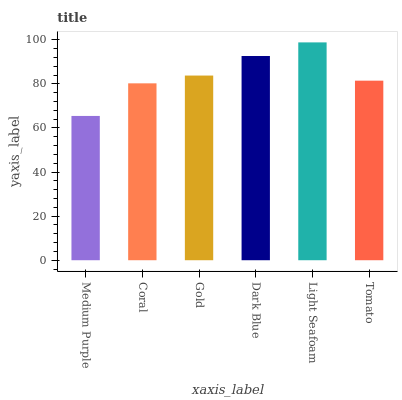Is Medium Purple the minimum?
Answer yes or no. Yes. Is Light Seafoam the maximum?
Answer yes or no. Yes. Is Coral the minimum?
Answer yes or no. No. Is Coral the maximum?
Answer yes or no. No. Is Coral greater than Medium Purple?
Answer yes or no. Yes. Is Medium Purple less than Coral?
Answer yes or no. Yes. Is Medium Purple greater than Coral?
Answer yes or no. No. Is Coral less than Medium Purple?
Answer yes or no. No. Is Gold the high median?
Answer yes or no. Yes. Is Tomato the low median?
Answer yes or no. Yes. Is Medium Purple the high median?
Answer yes or no. No. Is Gold the low median?
Answer yes or no. No. 